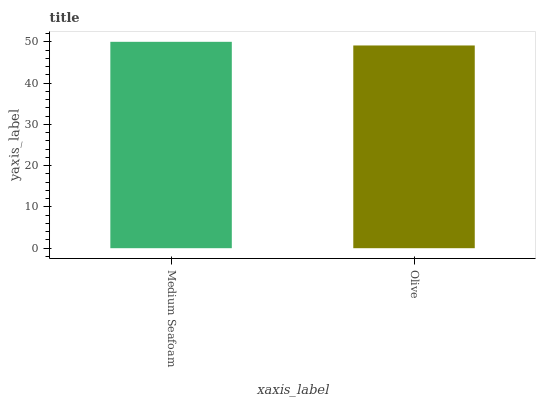Is Olive the minimum?
Answer yes or no. Yes. Is Medium Seafoam the maximum?
Answer yes or no. Yes. Is Olive the maximum?
Answer yes or no. No. Is Medium Seafoam greater than Olive?
Answer yes or no. Yes. Is Olive less than Medium Seafoam?
Answer yes or no. Yes. Is Olive greater than Medium Seafoam?
Answer yes or no. No. Is Medium Seafoam less than Olive?
Answer yes or no. No. Is Medium Seafoam the high median?
Answer yes or no. Yes. Is Olive the low median?
Answer yes or no. Yes. Is Olive the high median?
Answer yes or no. No. Is Medium Seafoam the low median?
Answer yes or no. No. 